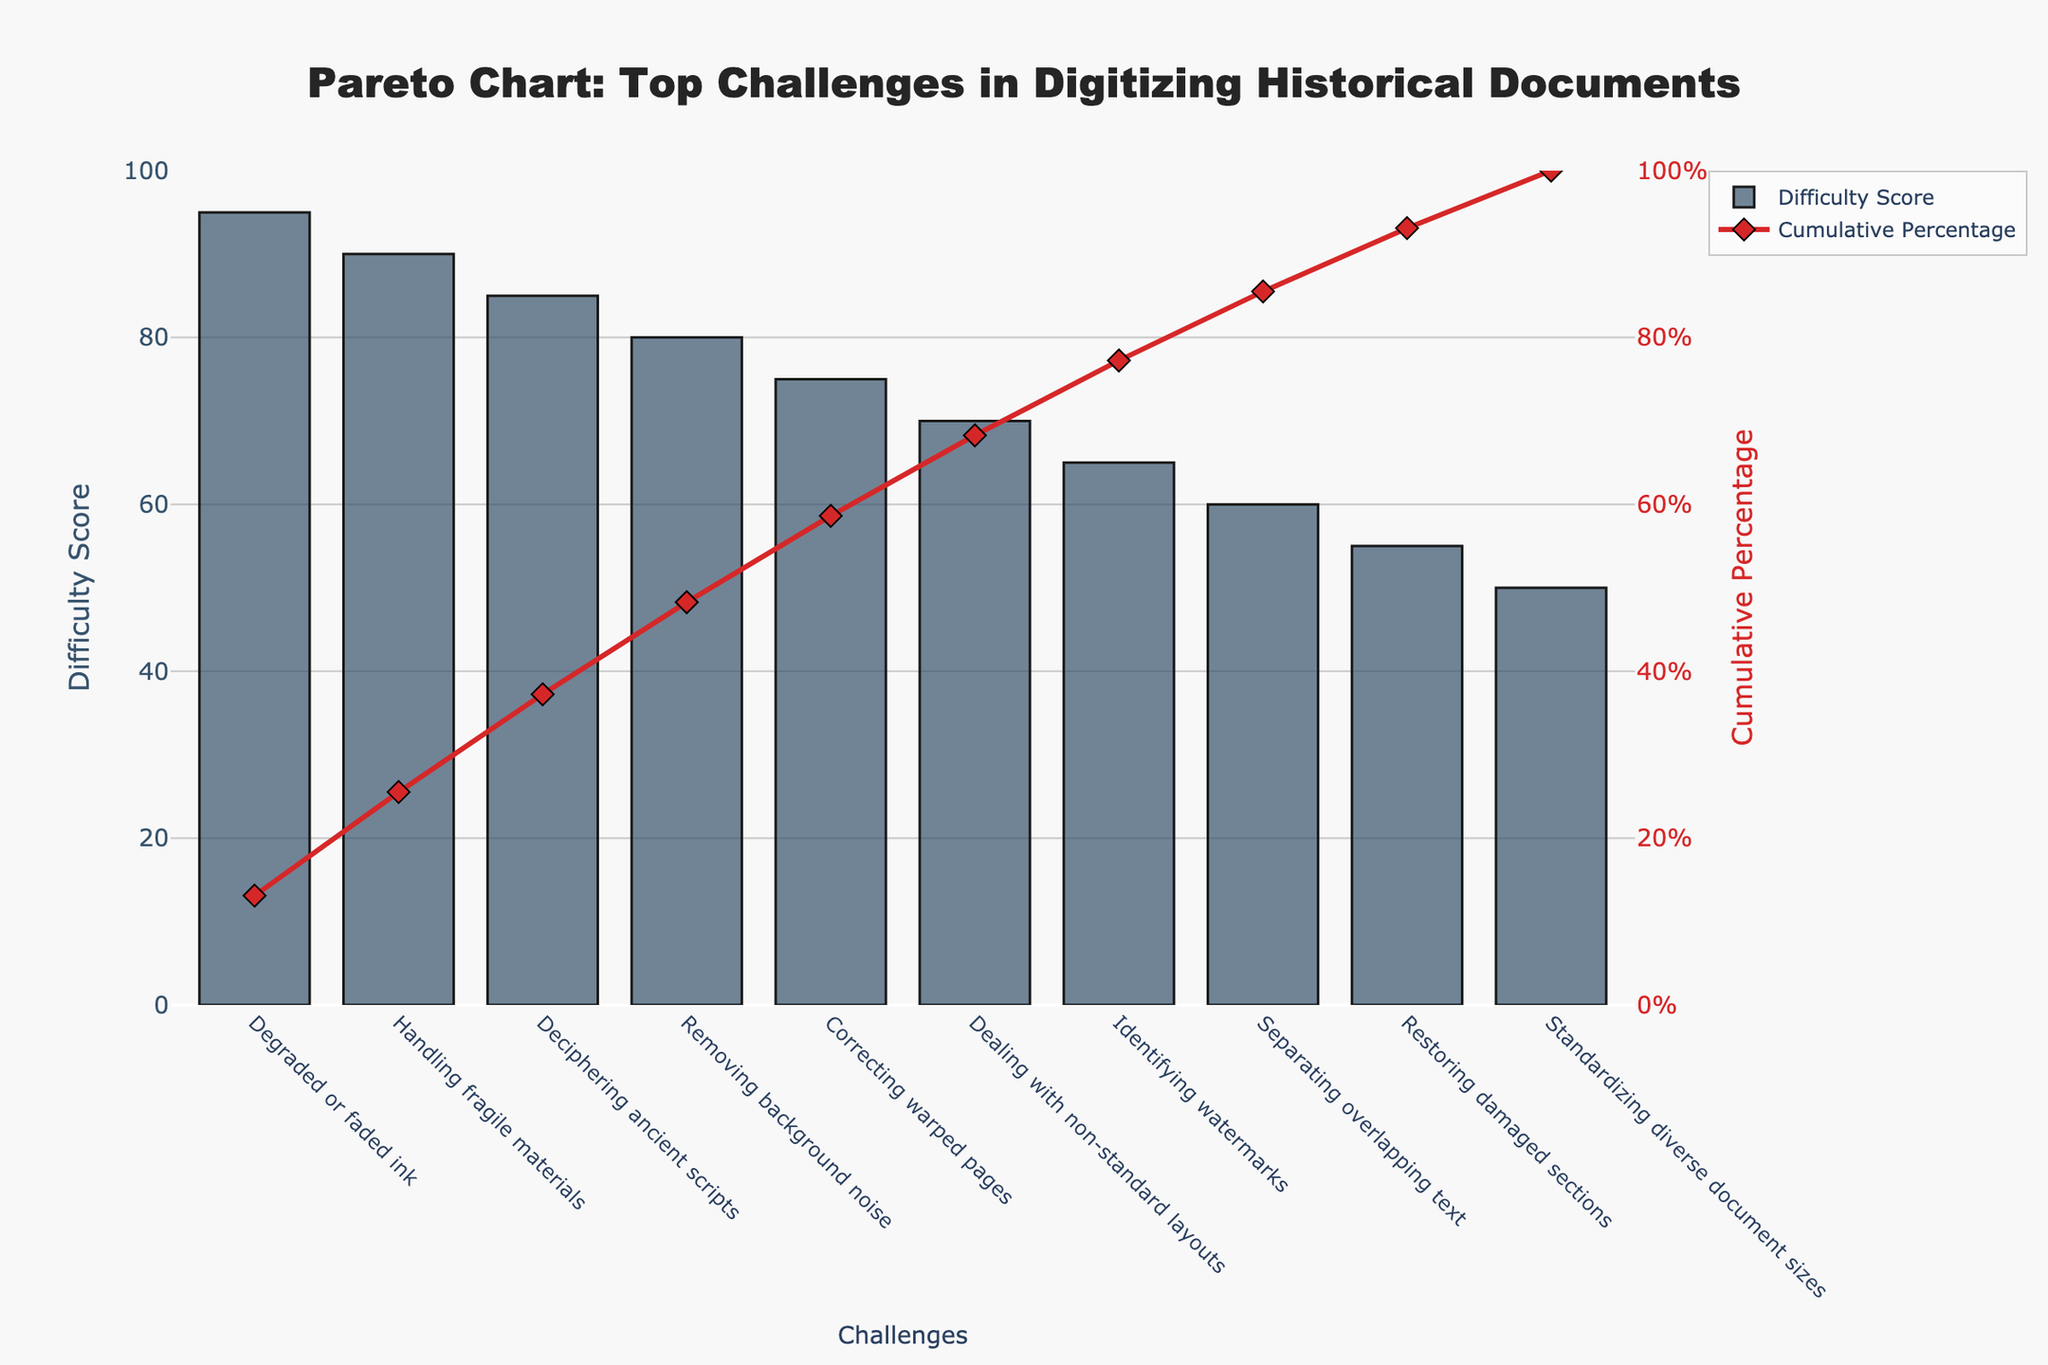What is the total number of challenges listed in the chart? Count the bars in the chart. There are 10 challenges listed.
Answer: 10 Which challenge has the highest difficulty score? Find the bar with the highest value on the y-axis. The "Degraded or faded ink" challenge is the highest at a difficulty score of 95.
Answer: Degraded or faded ink What is the cumulative percentage after the second challenge? Locate the cumulative percentage line on the second bar. The cumulative percentage after the "Handling fragile materials" challenge reaches 90.4%.
Answer: 90.4% How does the difficulty score of "Correcting warped pages" compare to "Separating overlapping text"? Identify the bars of both challenges. The difficulty score for "Correcting warped pages" is 75, while "Separating overlapping text" has a score of 60. Thus, "Correcting warped pages" has a higher difficulty score.
Answer: Correcting warped pages is higher What is the cumulative percentage after the first four challenges? Look at the cumulative percentage value after the fourth bar. The cumulative percentage after "Removing background noise" is 87.92%.
Answer: 87.92% Which challenge contributes the least to the overall difficulty? Find the bar with the lowest value on the y-axis. The "Standardizing diverse document sizes" challenge has the lowest difficulty score at 50.
Answer: Standardizing diverse document sizes How many challenges have a difficulty score greater than or equal to 80? Count the number of bars with values on the y-axis of 80 or more. The challenges are:
- Degraded or faded ink (95),
- Handling fragile materials (90),
- Deciphering ancient scripts (85),
- Removing background noise (80). There are 4 such challenges.
Answer: 4 What is the difference in difficulty score between the highest and lowest challenges? Subtract the lowest difficulty score from the highest. 95 (Degraded or faded ink) - 50 (Standardizing diverse document sizes) = 45.
Answer: 45 Which challenge closely follows "Deciphering ancient scripts" in difficulty score? Find the bar immediately after "Deciphering ancient scripts" challenge. The "Removing background noise" challenge follows closely with a score of 80 compared to 85.
Answer: Removing background noise At which challenge does the cumulative percentage exceed 50%? Look for the cumulative percentage line crossing the 50% marker. It exceeds 50% after the third challenge, "Deciphering ancient scripts," with a cumulative percentage of around 73.08%.
Answer: Deciphering ancient scripts 